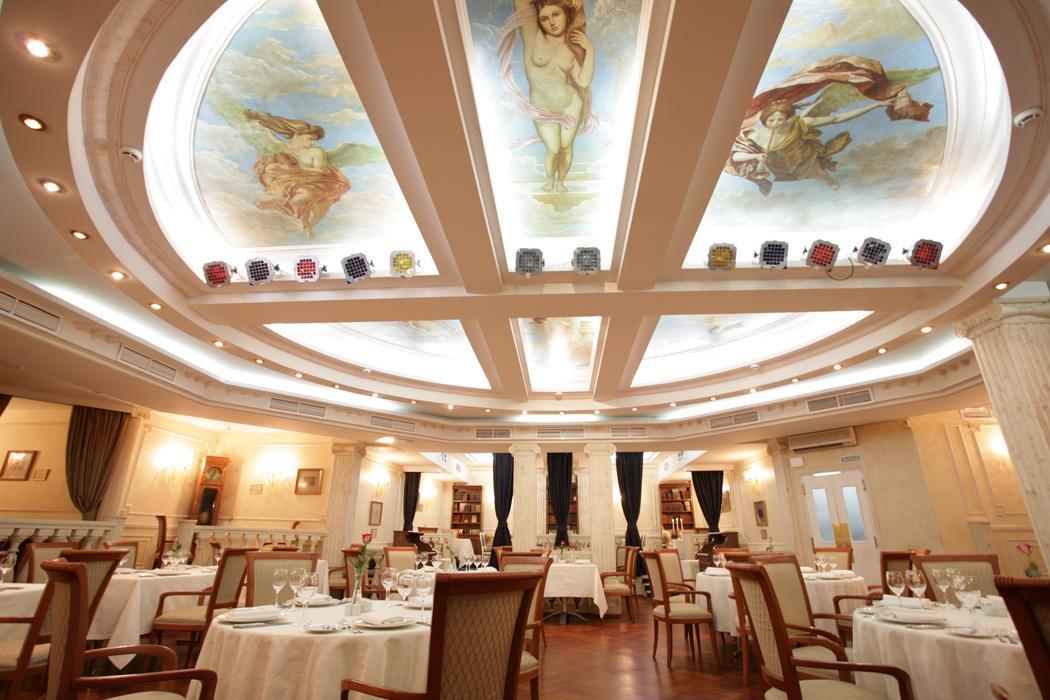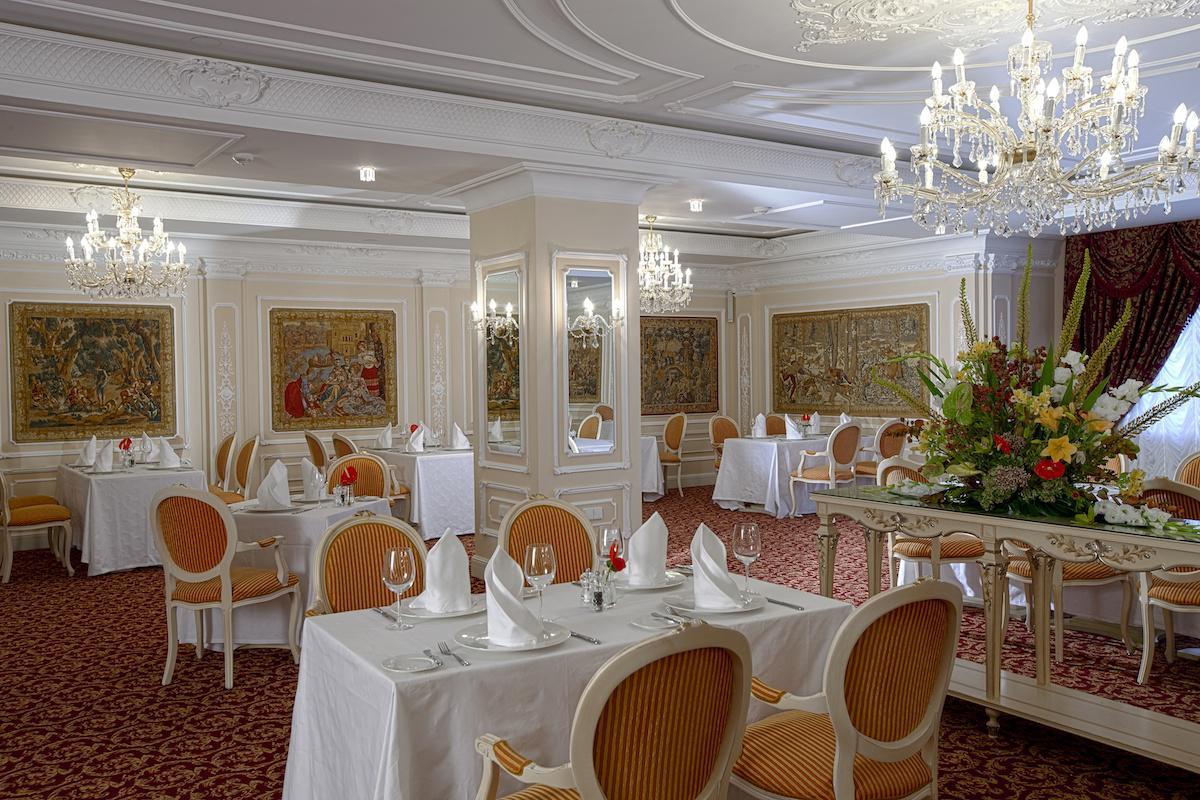The first image is the image on the left, the second image is the image on the right. For the images displayed, is the sentence "Tables are set in an unoccupied dining area in each of the images." factually correct? Answer yes or no. Yes. The first image is the image on the left, the second image is the image on the right. For the images displayed, is the sentence "In one image, a grand piano is at the far end of a room where many tables are set for dinner." factually correct? Answer yes or no. No. 